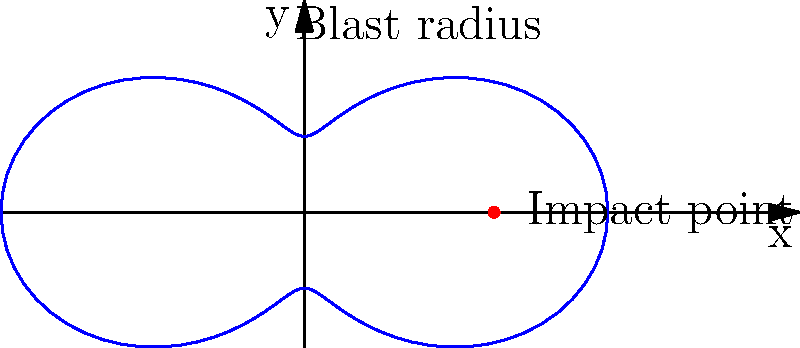As a tour guide at Pearl Harbor, you're explaining the impact of a hypothetical bomb blast. The blast radius is modeled by the polar equation $r = 5 + 3\cos(2\theta)$, where $r$ is in kilometers. What is the maximum distance the blast reaches from the impact point? To find the maximum distance of the blast:

1) The general equation is $r = 5 + 3\cos(2\theta)$.

2) The maximum value of $\cos(2\theta)$ is 1, which occurs when $2\theta = 0, 2\pi, 4\pi,$ etc.

3) The minimum value of $\cos(2\theta)$ is -1, which occurs when $2\theta = \pi, 3\pi,$ etc.

4) When $\cos(2\theta) = 1$, we get the maximum $r$:
   $r_{max} = 5 + 3(1) = 8$ km

5) When $\cos(2\theta) = -1$, we get the minimum $r$:
   $r_{min} = 5 + 3(-1) = 2$ km

6) The blast reaches its maximum distance when $r = r_{max} = 8$ km.

Therefore, the maximum distance the blast reaches from the impact point is 8 kilometers.
Answer: 8 kilometers 